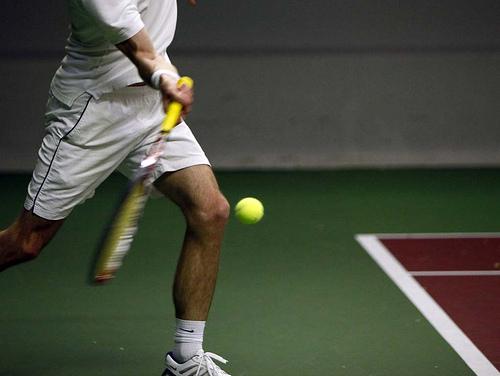What's on the wrist?
Short answer required. Wristband. What sport is this?
Answer briefly. Tennis. What color are his shorts?
Quick response, please. White. 